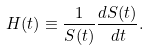Convert formula to latex. <formula><loc_0><loc_0><loc_500><loc_500>H ( t ) \equiv \frac { 1 } { S ( t ) } \frac { d S ( t ) } { d t } .</formula> 